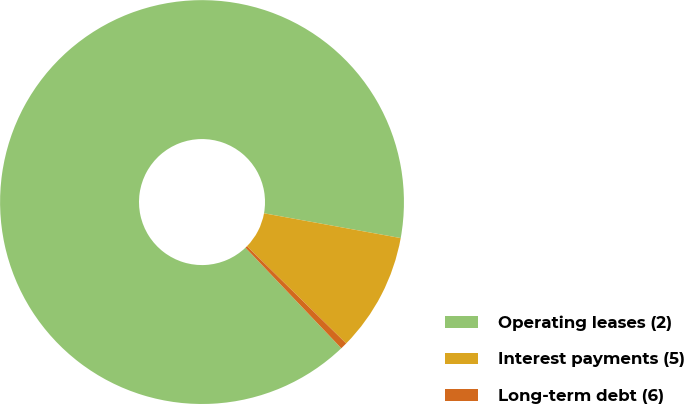Convert chart. <chart><loc_0><loc_0><loc_500><loc_500><pie_chart><fcel>Operating leases (2)<fcel>Interest payments (5)<fcel>Long-term debt (6)<nl><fcel>89.97%<fcel>9.49%<fcel>0.54%<nl></chart> 